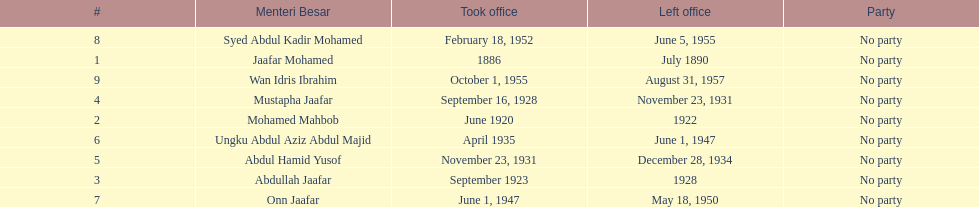Could you help me parse every detail presented in this table? {'header': ['#', 'Menteri Besar', 'Took office', 'Left office', 'Party'], 'rows': [['8', 'Syed Abdul Kadir Mohamed', 'February 18, 1952', 'June 5, 1955', 'No party'], ['1', 'Jaafar Mohamed', '1886', 'July 1890', 'No party'], ['9', 'Wan Idris Ibrahim', 'October 1, 1955', 'August 31, 1957', 'No party'], ['4', 'Mustapha Jaafar', 'September 16, 1928', 'November 23, 1931', 'No party'], ['2', 'Mohamed Mahbob', 'June 1920', '1922', 'No party'], ['6', 'Ungku Abdul Aziz Abdul Majid', 'April 1935', 'June 1, 1947', 'No party'], ['5', 'Abdul Hamid Yusof', 'November 23, 1931', 'December 28, 1934', 'No party'], ['3', 'Abdullah Jaafar', 'September 1923', '1928', 'No party'], ['7', 'Onn Jaafar', 'June 1, 1947', 'May 18, 1950', 'No party']]} Who took office after abdullah jaafar? Mustapha Jaafar. 